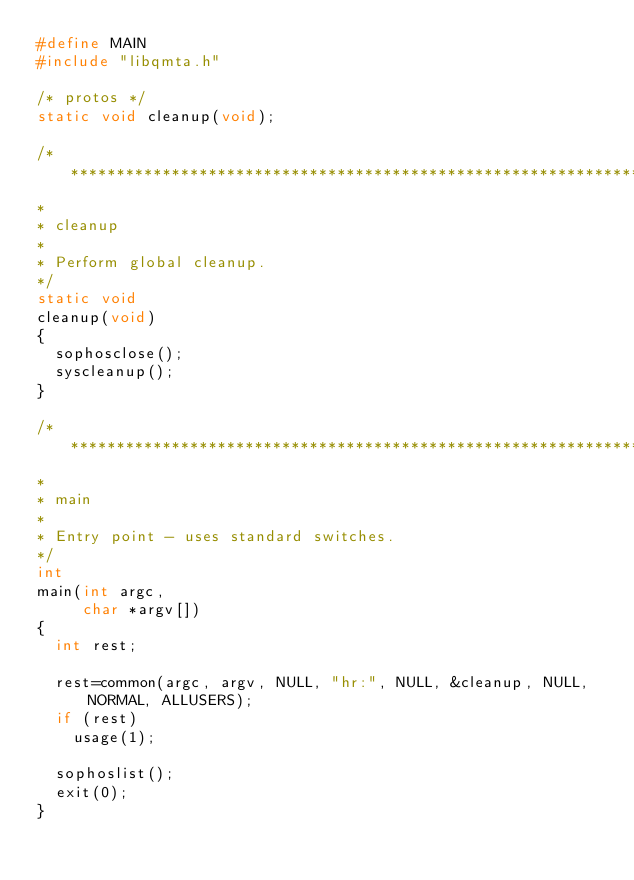Convert code to text. <code><loc_0><loc_0><loc_500><loc_500><_C_>#define MAIN
#include "libqmta.h"

/* protos */
static void cleanup(void);

/*******************************************************************************
*
*	cleanup
*
*	Perform global cleanup.
*/
static void
cleanup(void)
{
	sophosclose();
	syscleanup();
}

/*******************************************************************************
*
*	main
*
*	Entry point - uses standard switches.
*/
int
main(int argc,
     char *argv[])
{
	int rest;

	rest=common(argc, argv, NULL, "hr:", NULL, &cleanup, NULL, NORMAL, ALLUSERS);
	if (rest)
		usage(1);

	sophoslist();
	exit(0);
}
</code> 